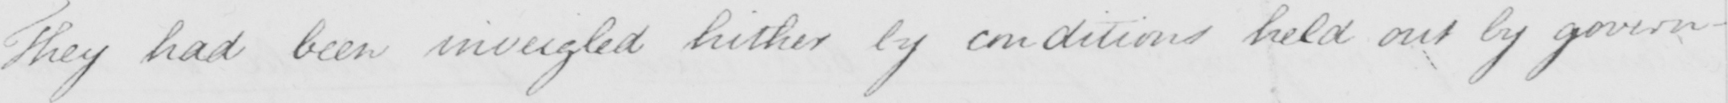What does this handwritten line say? They had been inveigled hither by conditions held out by govern- 